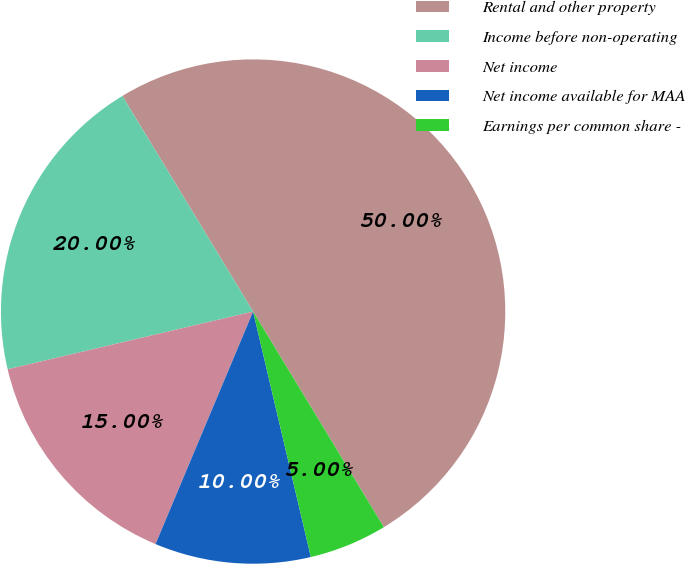<chart> <loc_0><loc_0><loc_500><loc_500><pie_chart><fcel>Rental and other property<fcel>Income before non-operating<fcel>Net income<fcel>Net income available for MAA<fcel>Earnings per common share -<nl><fcel>50.0%<fcel>20.0%<fcel>15.0%<fcel>10.0%<fcel>5.0%<nl></chart> 